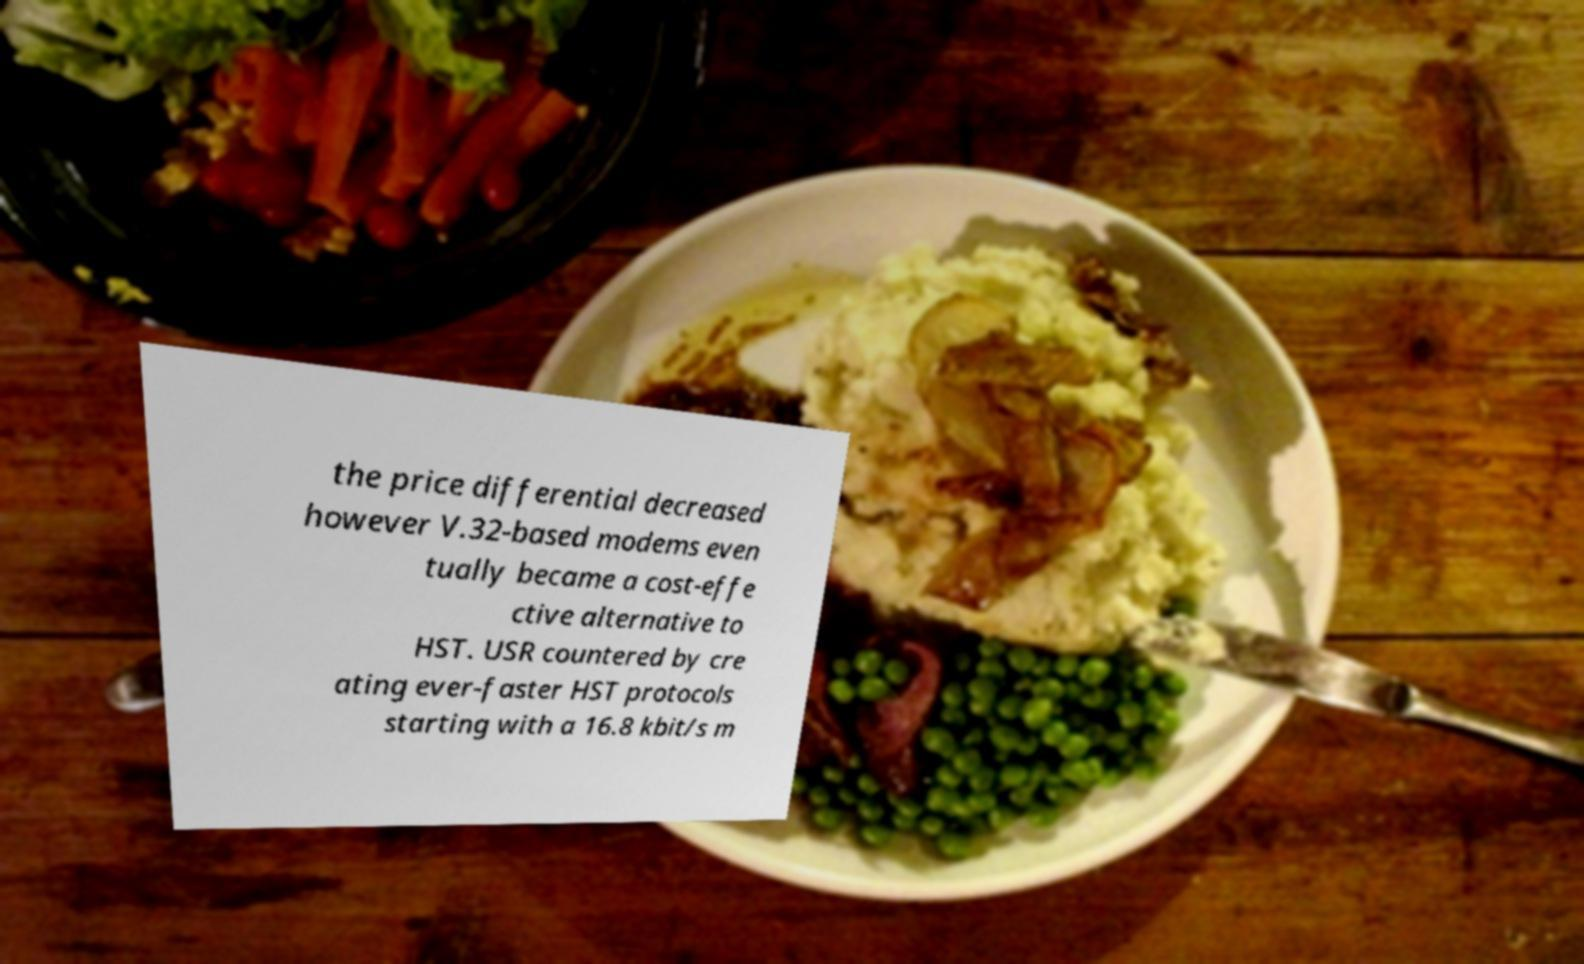Can you accurately transcribe the text from the provided image for me? the price differential decreased however V.32-based modems even tually became a cost-effe ctive alternative to HST. USR countered by cre ating ever-faster HST protocols starting with a 16.8 kbit/s m 